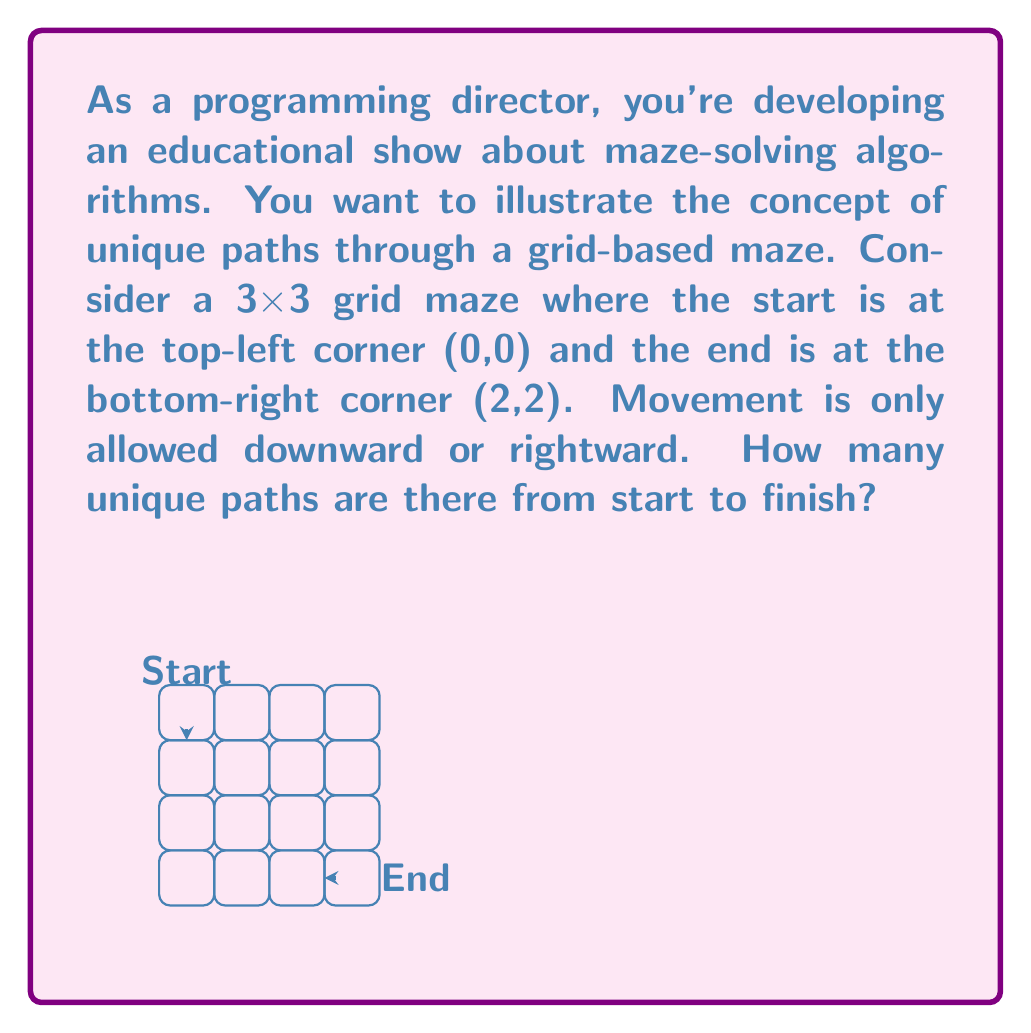Solve this math problem. Let's approach this step-by-step:

1) First, we need to understand that to reach the end (2,2) from (0,0), we always need to move 2 steps right and 2 steps down, regardless of the order.

2) This problem is equivalent to finding the number of ways to arrange 2 right moves and 2 down moves.

3) We can solve this using combinatorics. The total number of moves is 4 (2 right + 2 down), and we need to choose positions for either the right moves or the down moves.

4) This is a combination problem. We can calculate it using the formula:

   $$\binom{n}{k} = \frac{n!}{k!(n-k)!}$$

   Where $n$ is the total number of moves (4) and $k$ is the number of right (or down) moves (2).

5) Plugging in the numbers:

   $$\binom{4}{2} = \frac{4!}{2!(4-2)!} = \frac{4!}{2!2!}$$

6) Calculating:
   $$\frac{4 * 3 * 2 * 1}{(2 * 1)(2 * 1)} = \frac{24}{4} = 6$$

Therefore, there are 6 unique paths through this maze.
Answer: 6 unique paths 